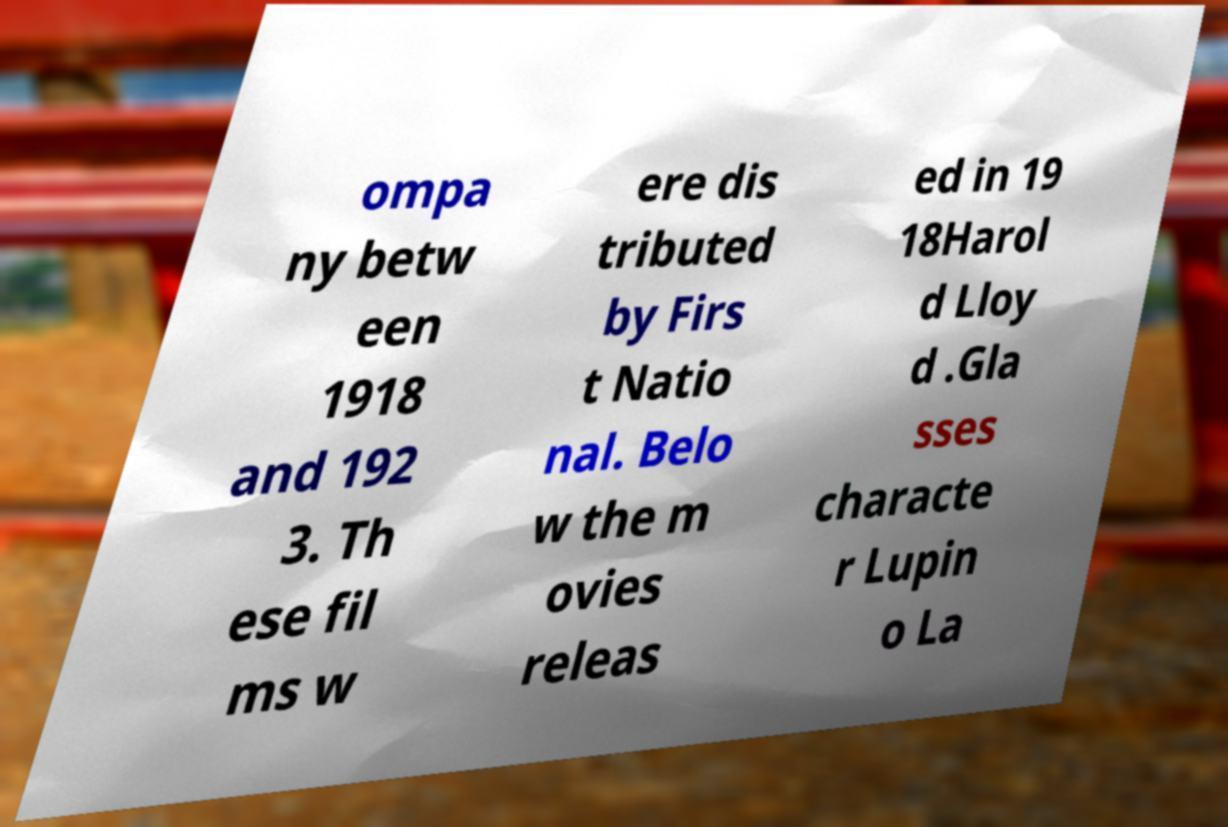I need the written content from this picture converted into text. Can you do that? ompa ny betw een 1918 and 192 3. Th ese fil ms w ere dis tributed by Firs t Natio nal. Belo w the m ovies releas ed in 19 18Harol d Lloy d .Gla sses characte r Lupin o La 